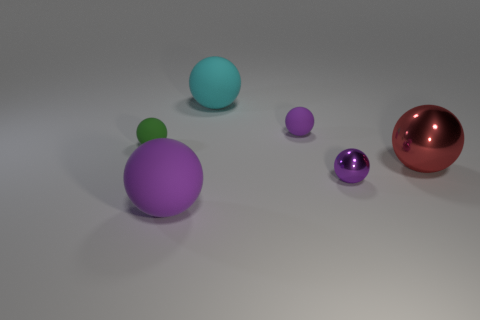Subtract all purple spheres. How many were subtracted if there are1purple spheres left? 2 Add 1 cyan spheres. How many objects exist? 7 Subtract all big red balls. How many balls are left? 5 Subtract 1 balls. How many balls are left? 5 Subtract all green spheres. How many spheres are left? 5 Subtract all yellow things. Subtract all purple matte things. How many objects are left? 4 Add 6 big shiny spheres. How many big shiny spheres are left? 7 Add 6 small purple matte balls. How many small purple matte balls exist? 7 Subtract 0 yellow blocks. How many objects are left? 6 Subtract all brown balls. Subtract all purple blocks. How many balls are left? 6 